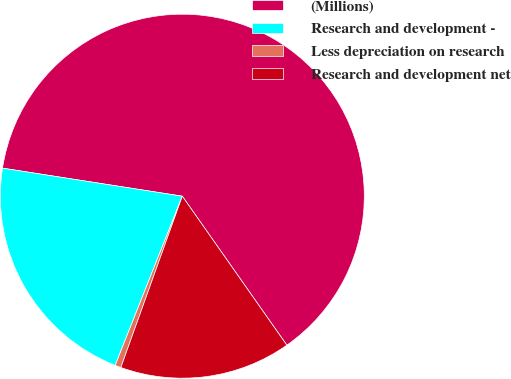Convert chart to OTSL. <chart><loc_0><loc_0><loc_500><loc_500><pie_chart><fcel>(Millions)<fcel>Research and development -<fcel>Less depreciation on research<fcel>Research and development net<nl><fcel>62.8%<fcel>21.45%<fcel>0.53%<fcel>15.22%<nl></chart> 